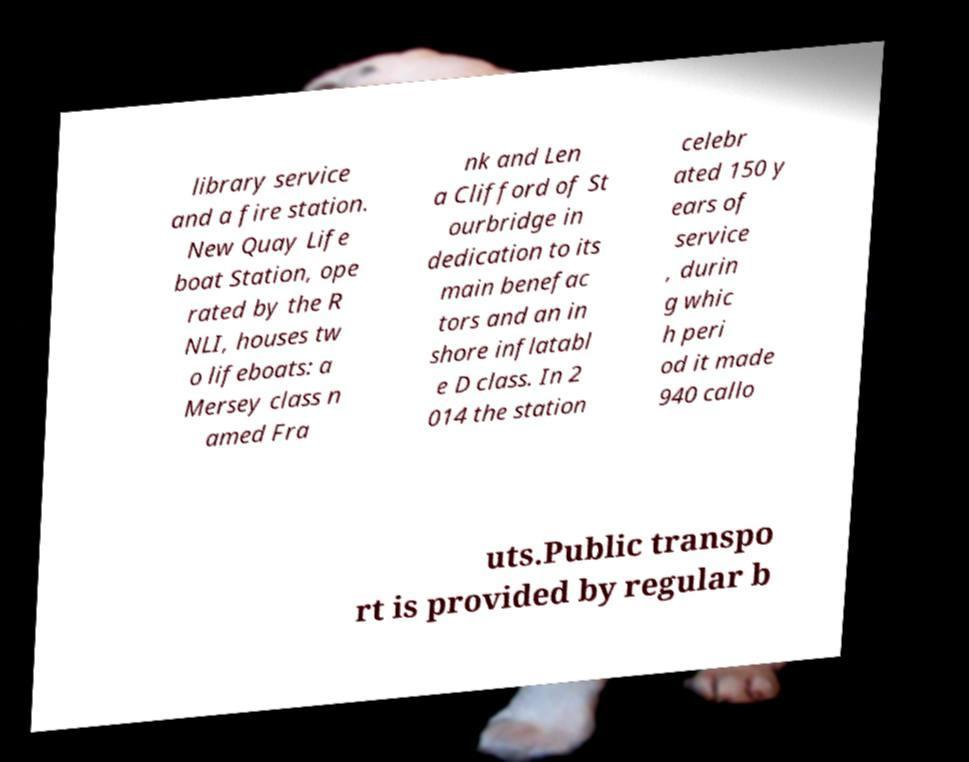I need the written content from this picture converted into text. Can you do that? library service and a fire station. New Quay Life boat Station, ope rated by the R NLI, houses tw o lifeboats: a Mersey class n amed Fra nk and Len a Clifford of St ourbridge in dedication to its main benefac tors and an in shore inflatabl e D class. In 2 014 the station celebr ated 150 y ears of service , durin g whic h peri od it made 940 callo uts.Public transpo rt is provided by regular b 